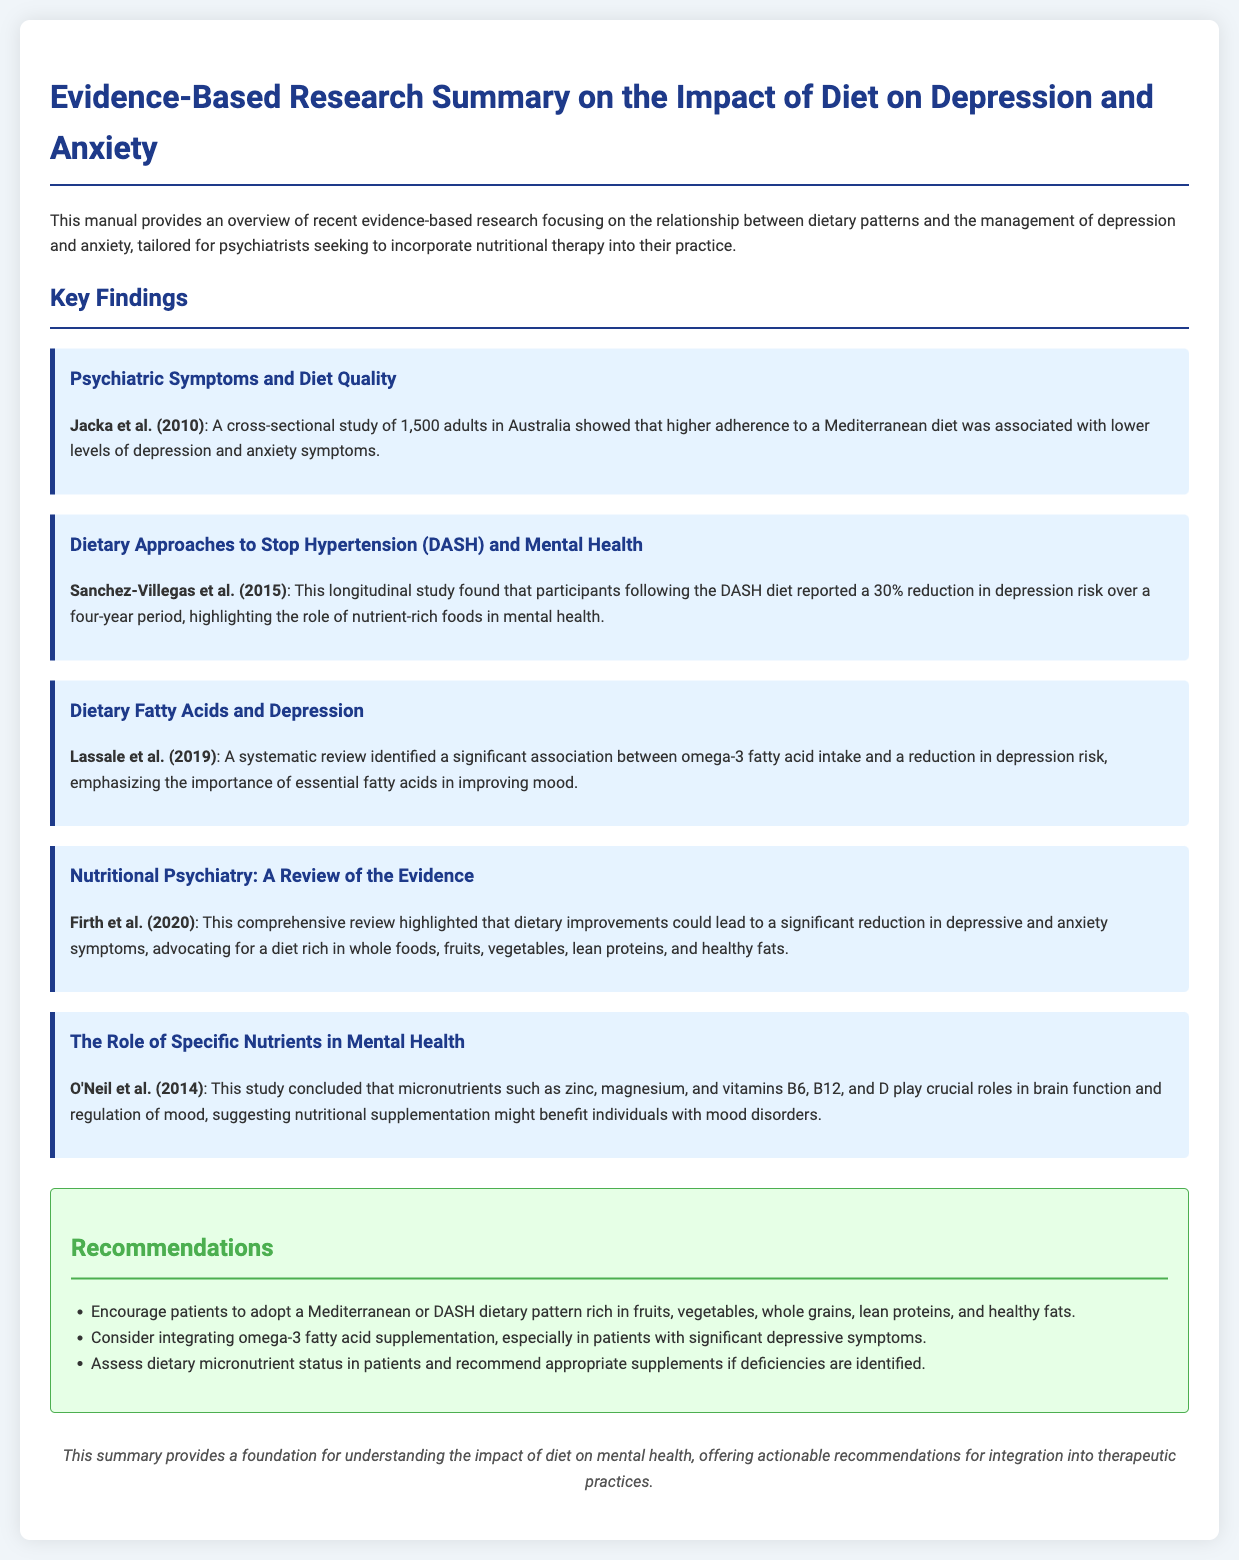What was the methodology used in the study by Jacka et al. (2010)? The study employed a cross-sectional methodology involving 1,500 adults in Australia.
Answer: Cross-sectional study What dietary pattern showed a 30% reduction in depression risk? The DASH diet was associated with a 30% reduction in depression risk over four years.
Answer: DASH diet Which micronutrient deficiencies might benefit individuals with mood disorders? The study suggests that deficiencies in zinc, magnesium, and vitamins B6, B12, and D could benefit from supplementation.
Answer: Zinc, magnesium, B6, B12, D What is a recommended dietary approach for patients? Patients are encouraged to adopt a Mediterranean or DASH dietary pattern.
Answer: Mediterranean or DASH dietary pattern What year was the review by Firth et al. published? The review highlighting dietary improvements and mental health was published in 2020.
Answer: 2020 Which type of fatty acid is suggested for supplementation in cases of significant depressive symptoms? Omega-3 fatty acids are recommended for supplementation.
Answer: Omega-3 fatty acids What was the main conclusion of the systematic review by Lassale et al. (2019)? The systematic review identified a significant association between omega-3 fatty acid intake and a reduction in depression risk.
Answer: Significant association What overall theme does the manual emphasize for managing mental health? The manual emphasizes the impact of diet on managing depression and anxiety.
Answer: Impact of diet What is the purpose of this manual? The manual provides an overview of evidence-based research on the relationship between dietary patterns and mental health.
Answer: Overview of evidence-based research on diet and mental health 